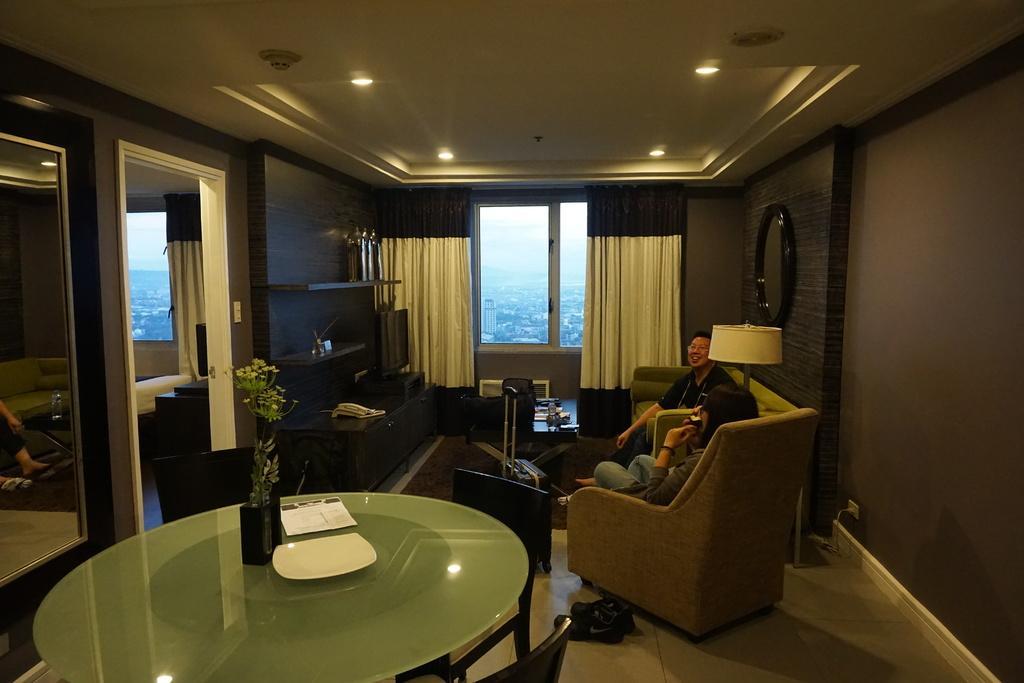Please provide a concise description of this image. In this picture we can see the inside view of the luxury living room in which a woman is sitting on the relaxing sofa and drinking tea, beside her man wearing black t- shirt is sitting on the sofa and smiling towards the camera. In front we can see the brown curtain and glass window. In front glass center table on which flower pot and tea cup is kept. Beside a wooden panel a mirror is attached to it and some floating shelves and another room. 